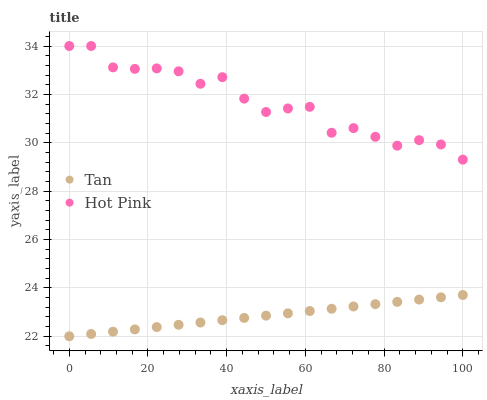Does Tan have the minimum area under the curve?
Answer yes or no. Yes. Does Hot Pink have the maximum area under the curve?
Answer yes or no. Yes. Does Hot Pink have the minimum area under the curve?
Answer yes or no. No. Is Tan the smoothest?
Answer yes or no. Yes. Is Hot Pink the roughest?
Answer yes or no. Yes. Is Hot Pink the smoothest?
Answer yes or no. No. Does Tan have the lowest value?
Answer yes or no. Yes. Does Hot Pink have the lowest value?
Answer yes or no. No. Does Hot Pink have the highest value?
Answer yes or no. Yes. Is Tan less than Hot Pink?
Answer yes or no. Yes. Is Hot Pink greater than Tan?
Answer yes or no. Yes. Does Tan intersect Hot Pink?
Answer yes or no. No. 